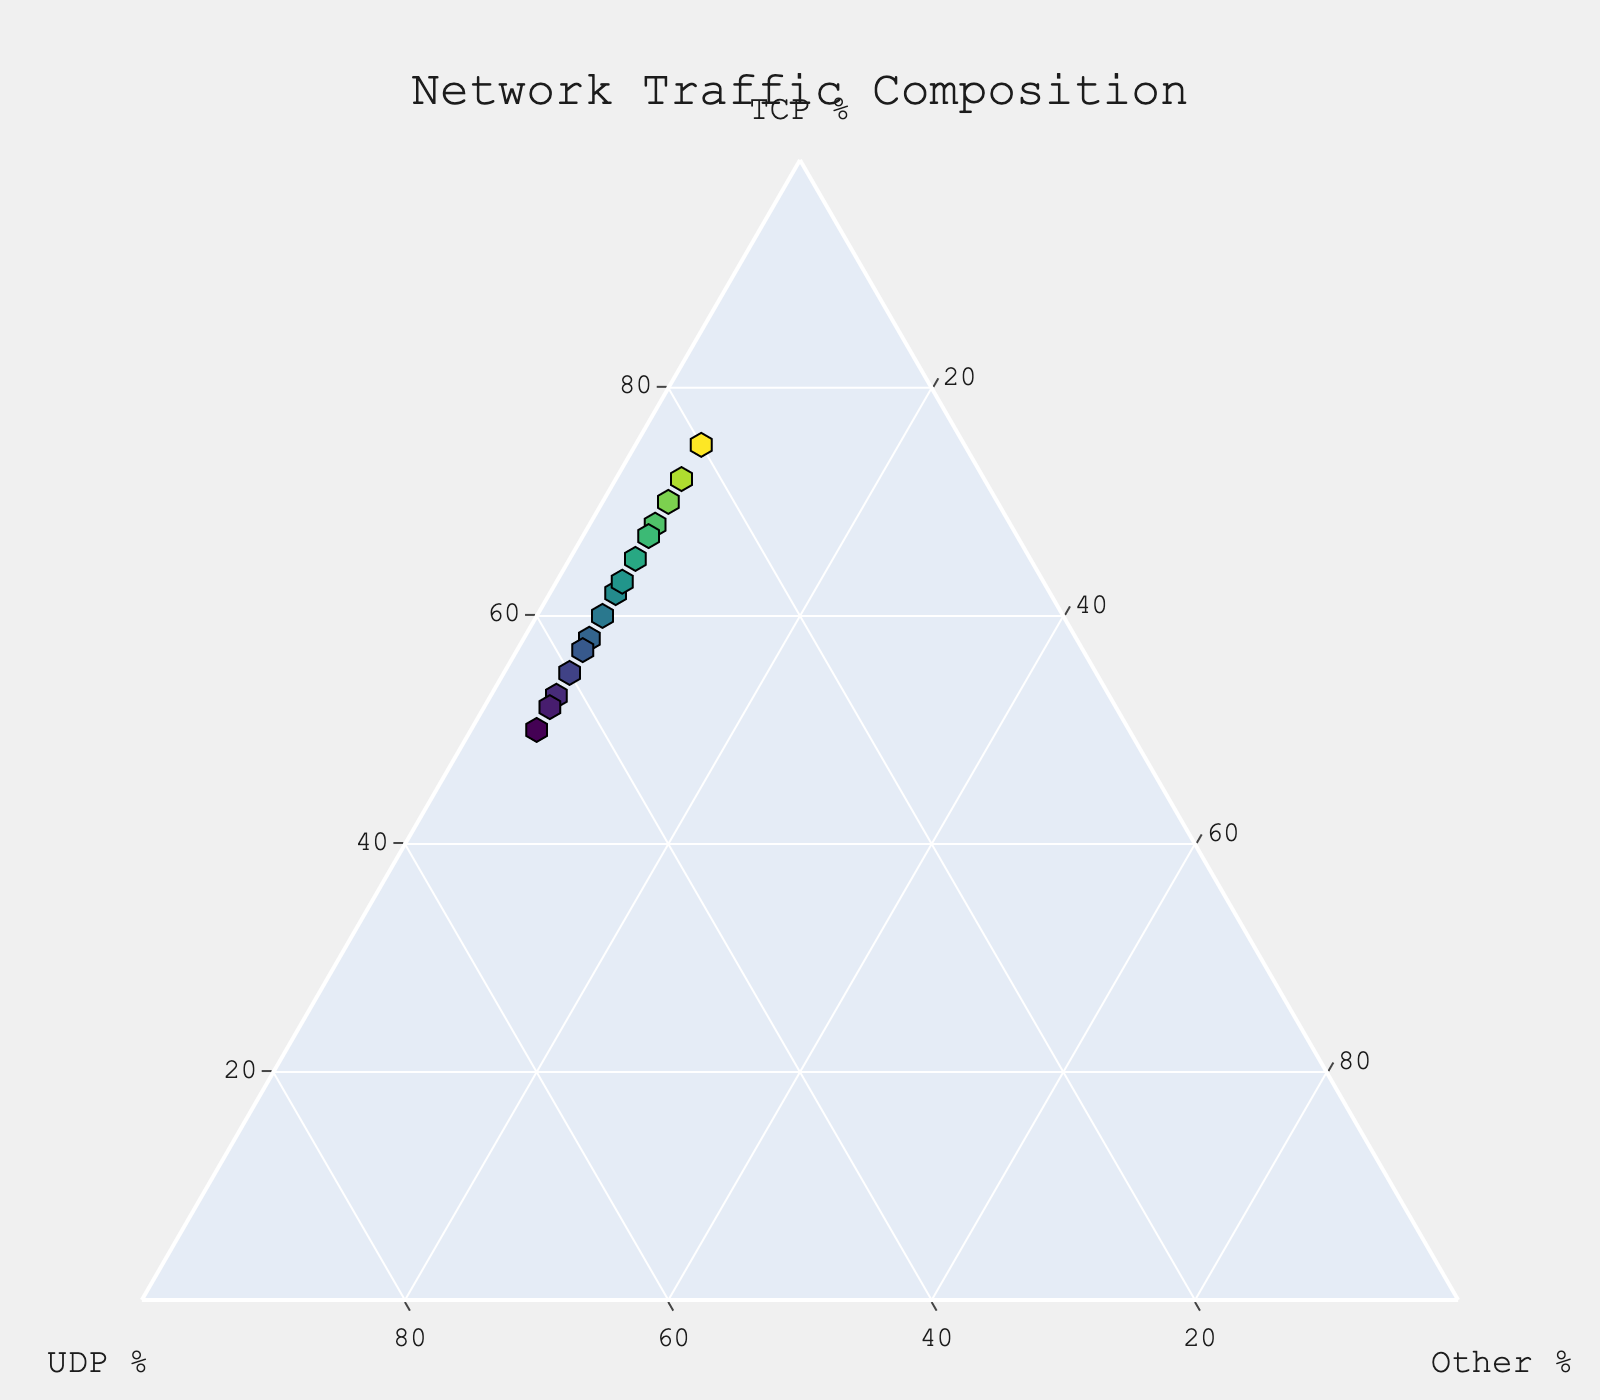What is the title of the plot? The title of the plot is displayed prominently at the top center of the figure. It is styled with a larger font and a clear color.
Answer: Network Traffic Composition How many data points are plotted on the ternary plot? By visually counting the number of hexagon markers on the ternary plot, we can determine the number of data points.
Answer: 15 What are the components shown on the ternary axes? The ternary plot has three components, each representing one side of the triangle and labeled accordingly.
Answer: TCP, UDP, Other Which data point has the highest TCP percentage? To find the data point with the highest TCP percentage, locate the marker furthest along the TCP axis. This data point will have the greatest distance from the 'Other' axis.
Answer: 75% What is the range of UDP values in the plot? By observing the markers along the UDP axis and identifying the minimum and maximum values, you can determine the range.
Answer: 20% to 45% Which axis represents the smallest percentage value for 'Other' protocols in all data points? Observing the 'Other' axis shows that all points along this axis have low values, specifically around the consistent smallest recorded percentage for 'Other'.
Answer: Other Which data points have an equal sum of TCP and UDP percentages? The sum of 55, 40 for TCP and UDP, and the sum of 50, 45 for TCP and UDP, exceed every other pair of points if compared manually.
Answer: 55% TCP, 40% UDP (5% Other) and 50% TCP, 45% UDP (5% Other) What is the other percentage for data points with a TCP percentage greater than 70% and UDP less than 25%? By filtering the points based on TCP > 70% and UDP < 25%, the 'Other' value for the identified point(s) can be determined.
Answer: 5% What is the average TCP percentage for all data points? Sum all TCP percentages (65 + 55 + 70 + 60 + 50 + 75 + 58 + 62 + 53 + 68 + 72 + 57 + 63 + 52 + 67 = 927) and divide by the number of data points (15) to find the average.
Answer: 61.8 Which protocol (TCP or UDP) generally has a larger composition across the data points? By visually comparing the distribution of points along TCP and UDP axes, determine which protocol has generally higher values. Most data points lean towards higher values for one of the protocols.
Answer: TCP 